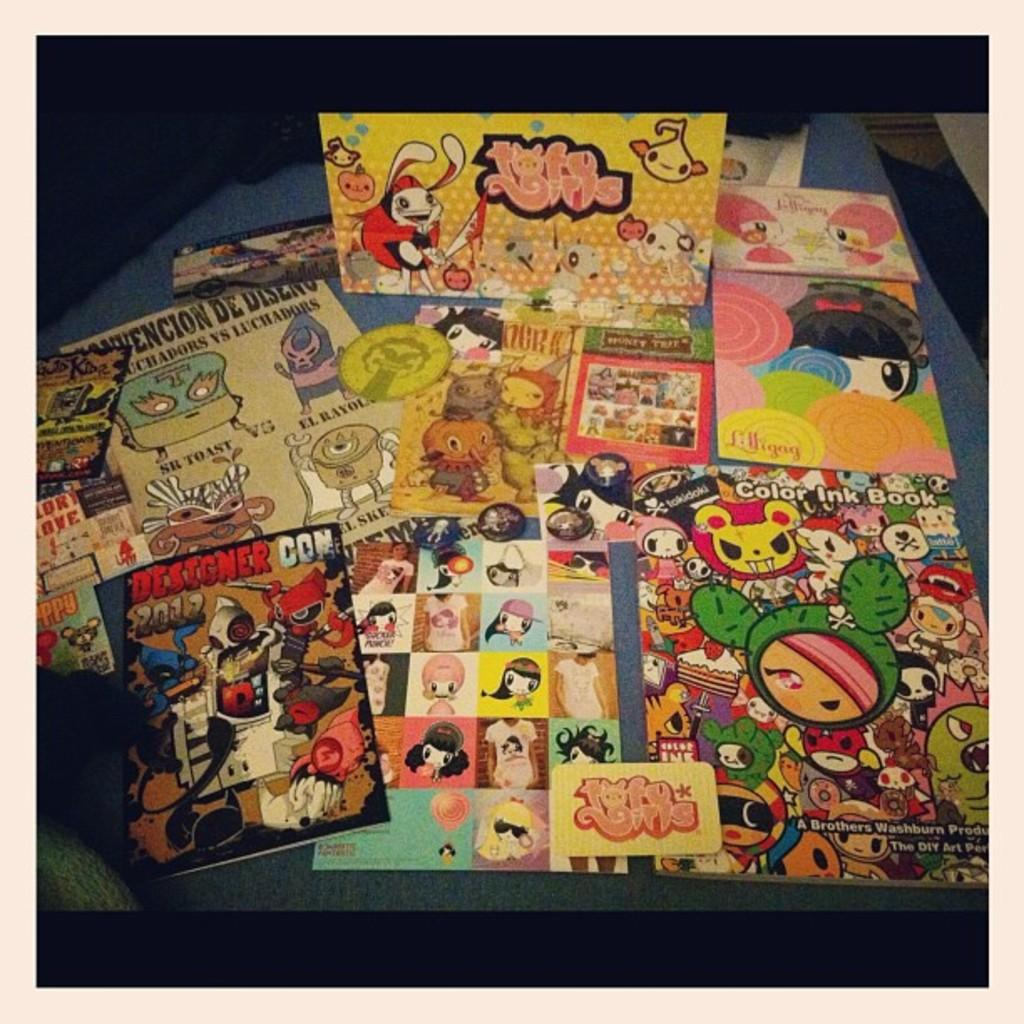<image>
Relay a brief, clear account of the picture shown. A table has a host of anime memorabilia on display from Designer Con. 